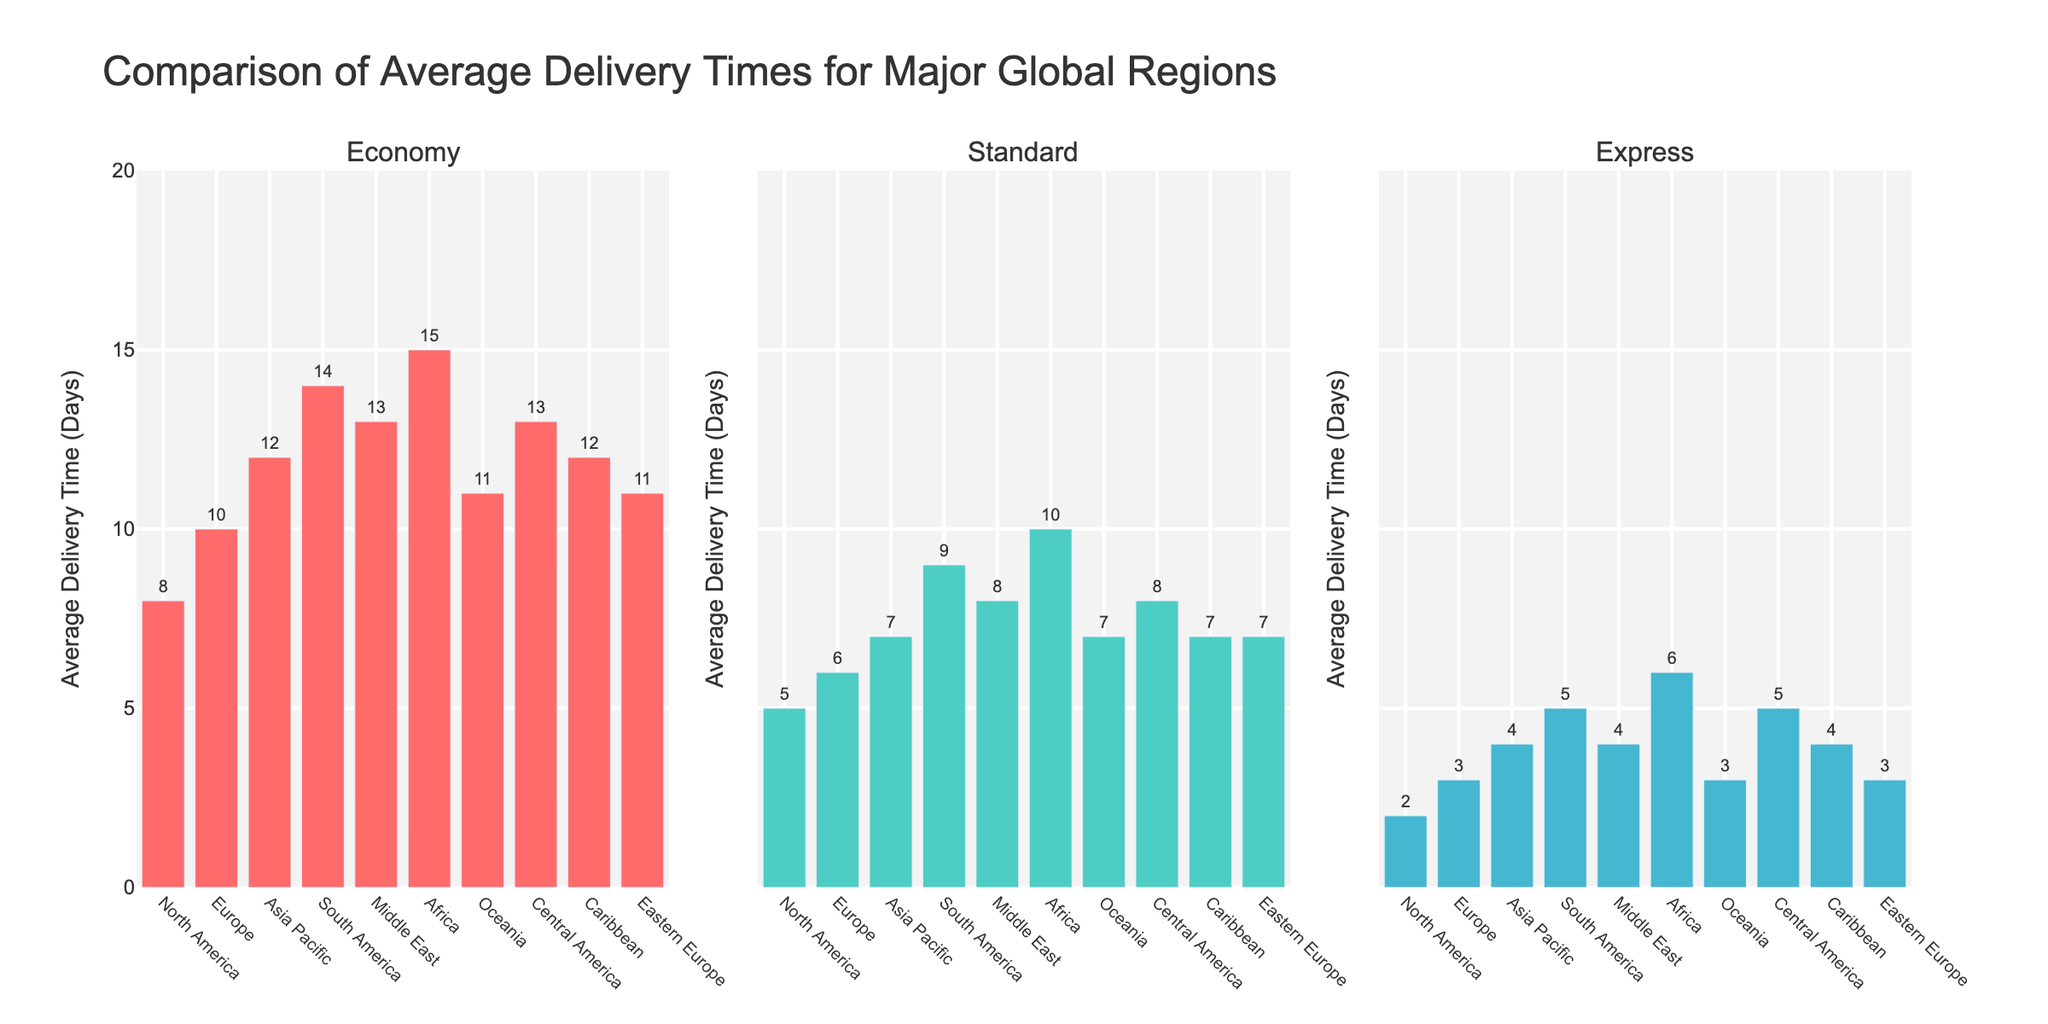What is the title of the figure? The title is displayed prominently at the top of the figure in a large font.
Answer: Financial Impact of Protocol Amendments on Clinical Trial Budgets Which study has the highest original budget? By examining the bars in the "Original vs Amended Budget" subplot (top-left), note that the tallest bar for the original budget appears for the "Cardiovascular Outcomes Trial".
Answer: Cardiovascular Outcomes Trial What is the percentage increase for the Pediatric Vaccine Study? In the "Percentage Increase by Study" subplot (top-right), locate the bar labeled "Pediatric Vaccine Study". The text above the bar shows the percentage increase.
Answer: 15% Which amendment type appears in the subplots for "Budget Comparison by Amendment Type" and with the highest percentage increase in the "Top 5 Studies by Budget Increase"? In both the "Budget Comparison by Amendment Type" (bottom-left) and the "Top 5 Studies by Budget Increase" (bottom-right) subplots, find the markers and bars respectively associated with "Sample Size Increase".
Answer: Sample Size Increase How does the amended budget for Rheumatoid Arthritis Biosimilar compare to its original budget? In the "Original vs Amended Budget" subplot (top-left), compare the height of the bars for "Rheumatoid Arthritis Biosimilar". The amended budget bar is slightly higher than the original budget bar. The text above the bars also indicates a specific dollar increase.
Answer: Higher by $375,000 Which study has the lowest percentage increase in its budget? In the "Percentage Increase by Study" subplot (top-right), find the shortest bar which represents the lowest percentage increase. This bar corresponds to the "Oncology Combo Therapy" study.
Answer: Oncology Combo Therapy What is the total amended budget for Alzheimer's Phase III and Immunotherapy Expansion studies? In the "Original vs Amended Budget" subplot (top-left), sum the amended budgets of these two studies. The text above the bars shows $5,720,000 for Alzheimer's Phase III and $9,900,000 for Immunotherapy Expansion.
Answer: $15,620,000 How many studies have a percentage increase of 10%? In the "Percentage Increase by Study" subplot (top-right), count the number of bars that have "10%" displayed above them. There are four such bars corresponding to Alzheimer's Phase III, Diabetes Long-Term Follow-up, Cardiovascular Outcomes Trial, and Immunotherapy Expansion.
Answer: 4 What is the comparison method utilized in the "Top 5 Studies by Budget Increase" subplot? The "Top 5 Studies by Budget Increase" (bottom-right) subplot sorts and displays the studies in descending order based on the percentage increase in their budgets.
Answer: Sort and display by descending percentage increase Which study has the highest percentage increase in the "Top 5 Studies by Budget Increase" subplot? In the "Top 5 Studies by Budget Increase" subplot (bottom-right), check the tallest bar which shows the highest percentage increase. It corresponds to "Dosing Schedule Adjustment" in the Rare Disease Gene Therapy study.
Answer: Rare Disease Gene Therapy What amendment type results in the highest amended budget overall? In the "Budget Comparison by Amendment Type" subplot (bottom-left), observe the scatter plot markers. The highest overall amended budget corresponds to "Endpoint Modification" in the Cardiovascular Outcomes Trial, as shown by the highest y-value.
Answer: Endpoint Modification 